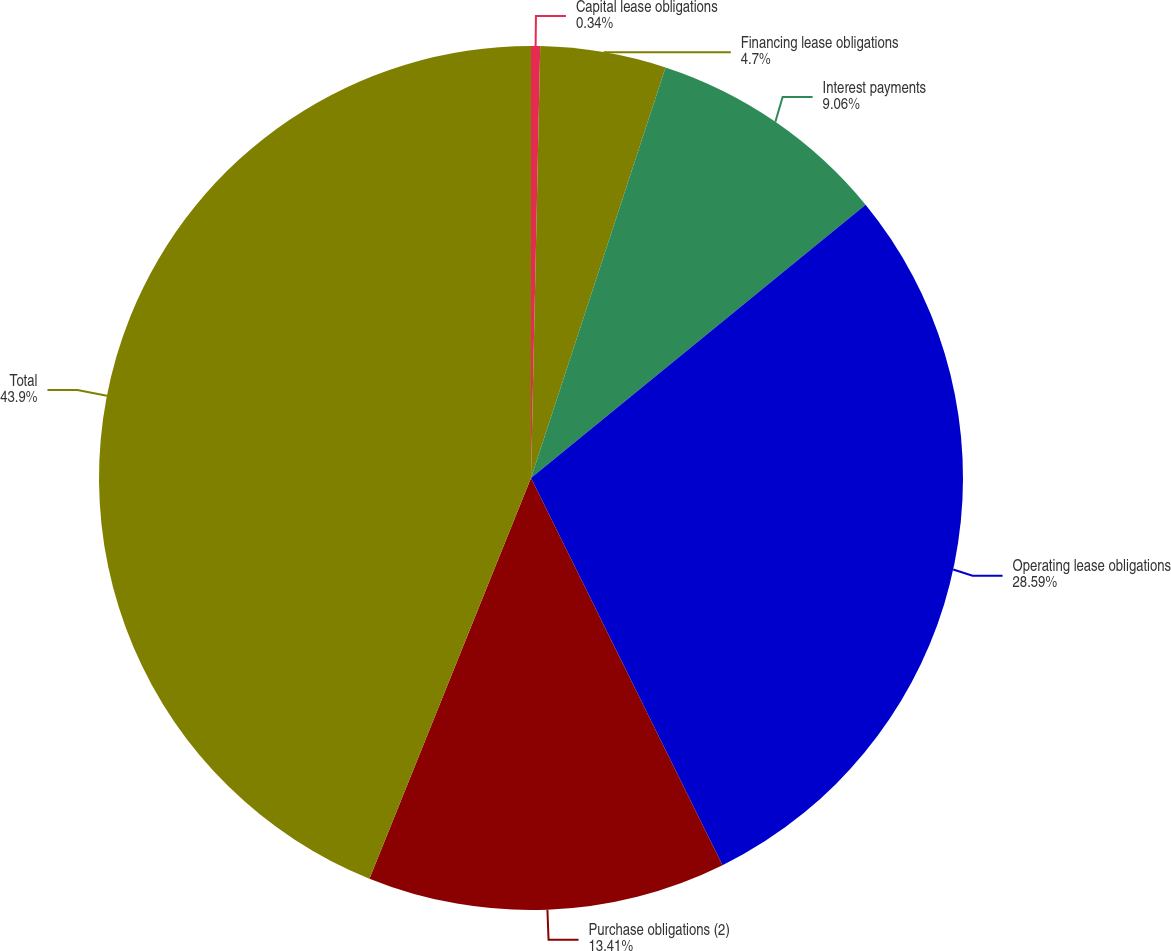<chart> <loc_0><loc_0><loc_500><loc_500><pie_chart><fcel>Capital lease obligations<fcel>Financing lease obligations<fcel>Interest payments<fcel>Operating lease obligations<fcel>Purchase obligations (2)<fcel>Total<nl><fcel>0.34%<fcel>4.7%<fcel>9.06%<fcel>28.59%<fcel>13.41%<fcel>43.9%<nl></chart> 